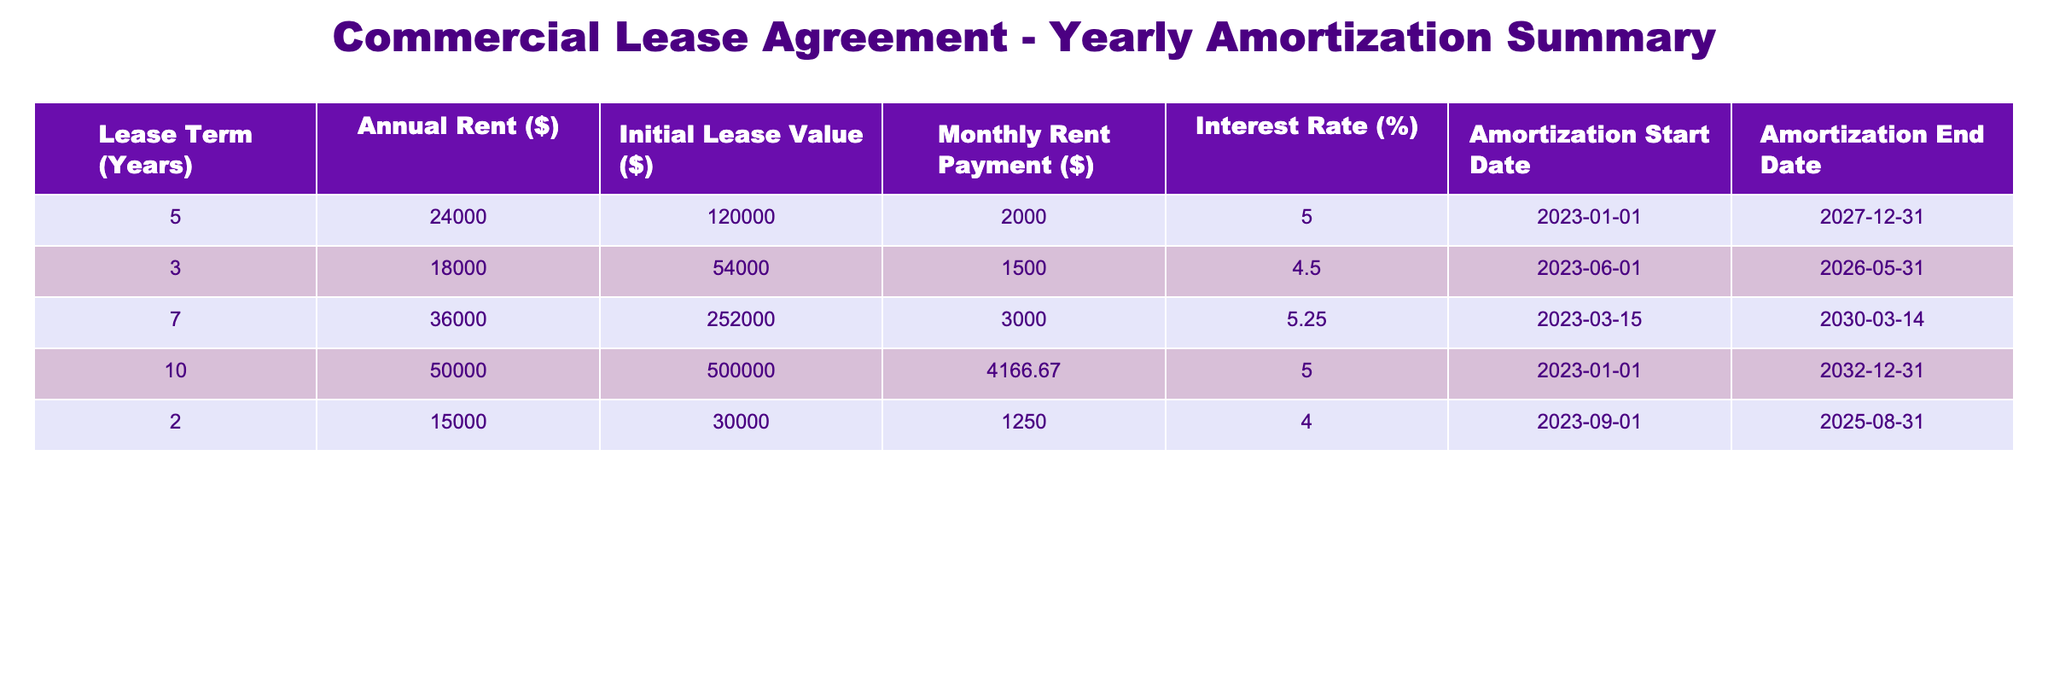What is the annual rent for the lease with the shortest term? The lease with the shortest term is for 2 years and has an annual rent of $15,000.
Answer: $15,000 What is the monthly rent payment for the 10-year lease? The 10-year lease's monthly rent payment is listed as $4,166.67.
Answer: $4,166.67 Is the interest rate for the 7-year lease higher than that of the 5-year lease? The 7-year lease has an interest rate of 5.25%, while the 5-year lease has an interest rate of 5%. Since 5.25% is greater than 5%, the statement is true.
Answer: Yes What is the total initial lease value of all leases combined? To find the total initial lease value, we add up the values: 120,000 + 54,000 + 252,000 + 500,000 + 30,000 = 956,000.
Answer: $956,000 Which lease has the highest annual rent? Reviewing the table, the 10-year lease has the highest annual rent at $50,000.
Answer: $50,000 What is the average monthly rent payment across all leases? To find the average monthly rent payment, sum all monthly payments: 2,000 + 1,500 + 3,000 + 4,166.67 + 1,250 = 11,916.67. There are 5 leases, so the average is 11,916.67 / 5 = 2,383.33.
Answer: $2,383.33 Does the annual rent for the lease starting on September 1, 2023, exceed $15,000? The lease starting on September 1, 2023, has an annual rent of $15,000, which does not exceed $15,000. Therefore, the statement is false.
Answer: No What is the difference in annual rent between the longest and shortest lease terms? The longest lease term is 10 years with an annual rent of $50,000, and the shortest is 2 years with an annual rent of $15,000. The difference is 50,000 - 15,000 = 35,000.
Answer: $35,000 What is the earliest amortization start date in the table? The earliest amortization start date is January 1, 2023, which belongs to the 5-year lease.
Answer: January 1, 2023 